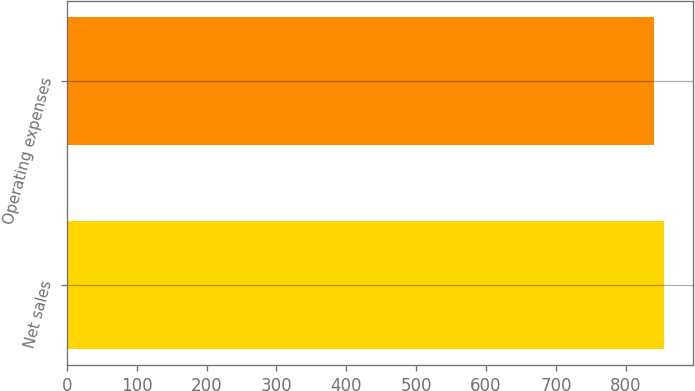Convert chart. <chart><loc_0><loc_0><loc_500><loc_500><bar_chart><fcel>Net sales<fcel>Operating expenses<nl><fcel>854<fcel>840<nl></chart> 